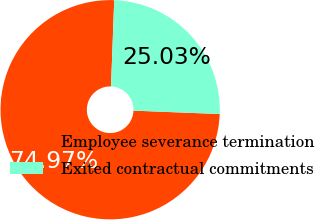<chart> <loc_0><loc_0><loc_500><loc_500><pie_chart><fcel>Employee severance termination<fcel>Exited contractual commitments<nl><fcel>74.97%<fcel>25.03%<nl></chart> 